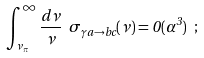<formula> <loc_0><loc_0><loc_500><loc_500>\int ^ { \infty } _ { \nu _ { \pi } } \frac { d \nu } { \nu } \ \sigma _ { \gamma a \rightarrow b c } ( \nu ) = 0 ( \alpha ^ { 3 } ) \ ;</formula> 